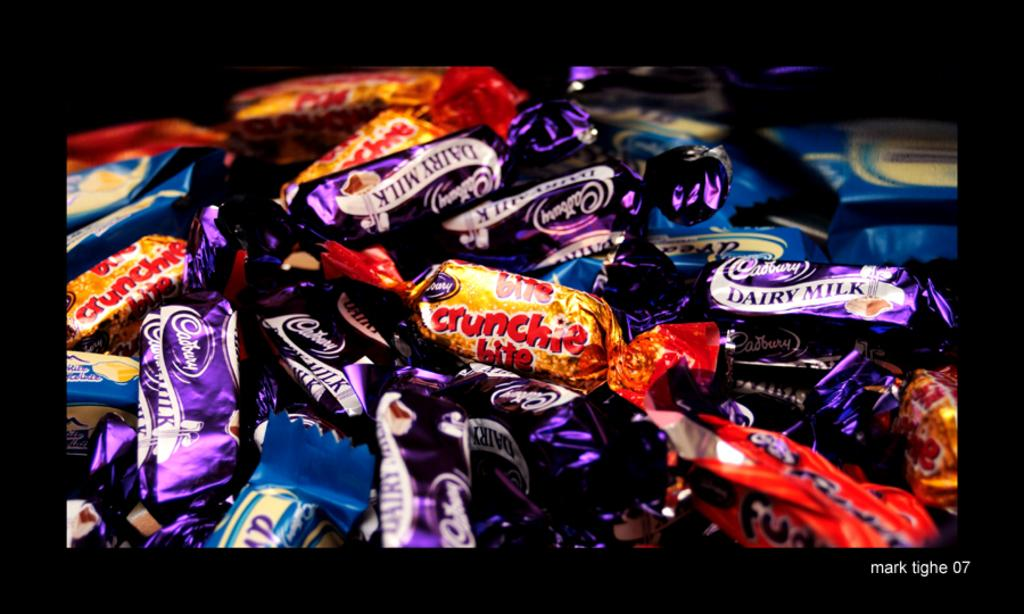What types of food items are present in the image? The image contains different types of chocolates. Is there any text present in the image? Yes, there is text at the bottom right of the image. How many snails can be seen crawling on the chocolates in the image? There are no snails present in the image; it only contains chocolates and text. 